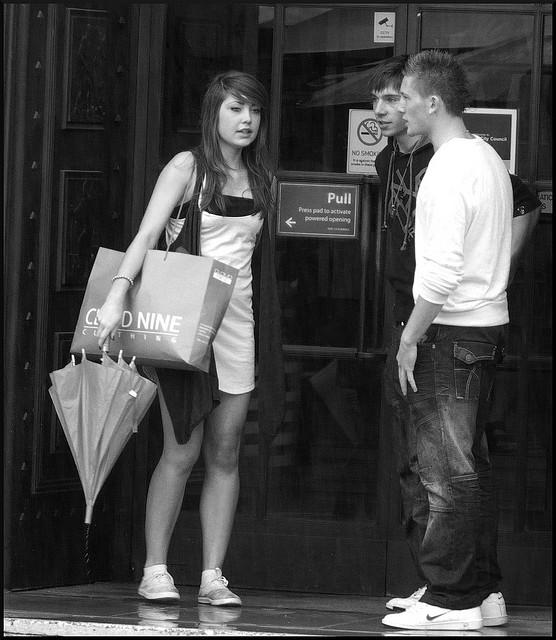What are the boys doing?

Choices:
A) interrogating her
B) being friendly
C) asking favor
D) being curious being friendly 